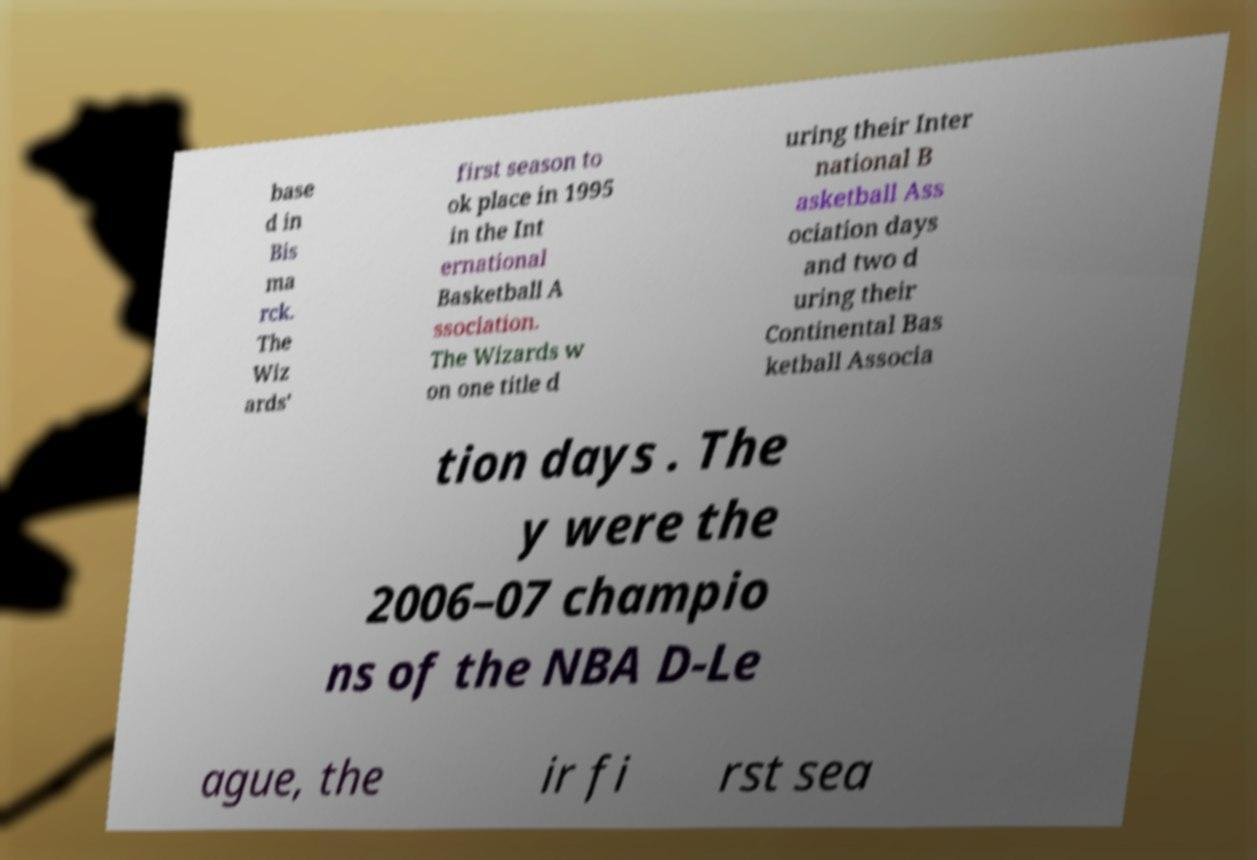Please identify and transcribe the text found in this image. base d in Bis ma rck. The Wiz ards' first season to ok place in 1995 in the Int ernational Basketball A ssociation. The Wizards w on one title d uring their Inter national B asketball Ass ociation days and two d uring their Continental Bas ketball Associa tion days . The y were the 2006–07 champio ns of the NBA D-Le ague, the ir fi rst sea 